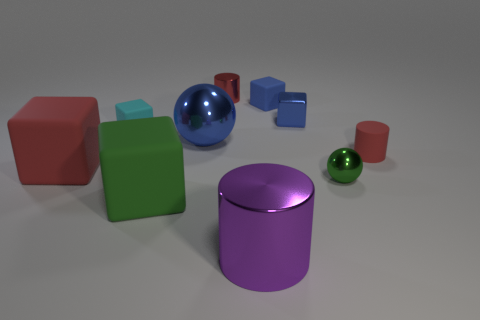How many red cylinders must be subtracted to get 1 red cylinders? 1 Subtract all small metallic cylinders. How many cylinders are left? 2 Subtract all blue spheres. How many spheres are left? 1 Subtract all balls. How many objects are left? 8 Subtract 0 cyan cylinders. How many objects are left? 10 Subtract 3 cylinders. How many cylinders are left? 0 Subtract all green spheres. Subtract all purple cylinders. How many spheres are left? 1 Subtract all yellow blocks. How many red balls are left? 0 Subtract all tiny blue metal blocks. Subtract all tiny cyan cubes. How many objects are left? 8 Add 5 small blue matte cubes. How many small blue matte cubes are left? 6 